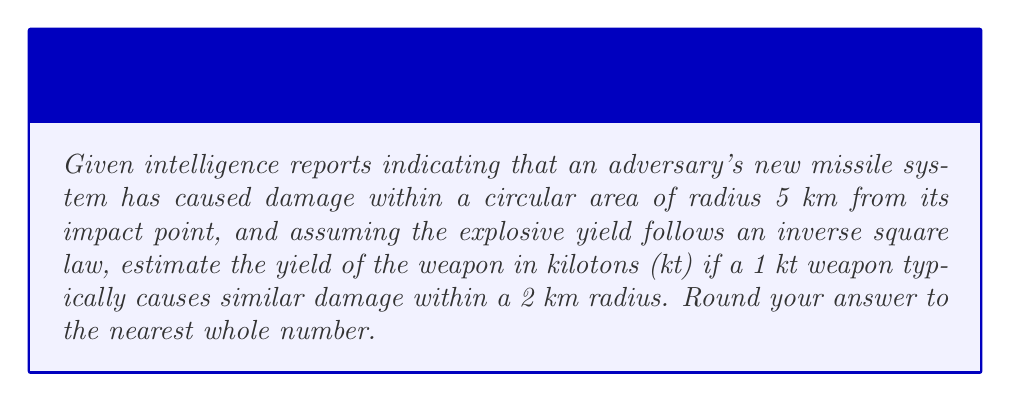Help me with this question. To solve this inverse problem, we'll follow these steps:

1) Let's define variables:
   $Y_1$ = yield of the known weapon (1 kt)
   $R_1$ = radius of damage for the known weapon (2 km)
   $Y_2$ = yield of the unknown weapon (what we're solving for)
   $R_2$ = radius of damage for the unknown weapon (5 km)

2) The inverse square law states that the intensity of an effect is inversely proportional to the square of the distance from the source. In this case, we can say:

   $\frac{Y_1}{R_1^2} = \frac{Y_2}{R_2^2}$

3) Substituting the known values:

   $\frac{1}{2^2} = \frac{Y_2}{5^2}$

4) Simplify:

   $\frac{1}{4} = \frac{Y_2}{25}$

5) Cross multiply:

   $25 \cdot \frac{1}{4} = Y_2$

6) Solve for $Y_2$:

   $Y_2 = \frac{25}{4} = 6.25$ kt

7) Rounding to the nearest whole number:

   $Y_2 \approx 6$ kt

Therefore, based on the observed damage radius and the inverse square law assumption, we estimate the yield of the adversary's weapon to be approximately 6 kilotons.
Answer: 6 kt 